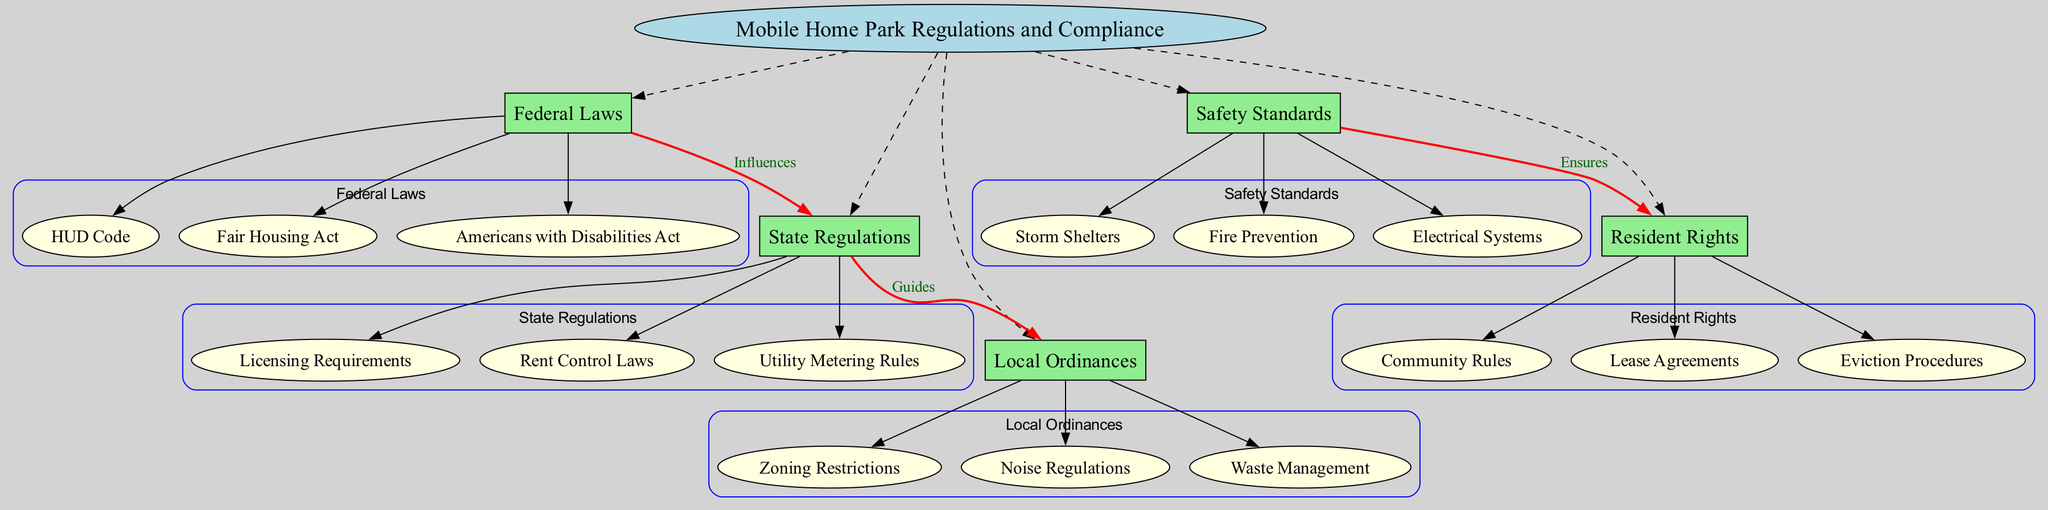What is the central concept of the diagram? The central concept is explicitly stated in the diagram at the center. After reviewing the diagram, it is confirmed to be "Mobile Home Park Regulations and Compliance."
Answer: Mobile Home Park Regulations and Compliance How many main nodes are there? The diagram lists five main nodes connected to the central concept. Counting these nodes yields a total of five.
Answer: 5 Which federal law relates to housing? One of the sub-nodes listed under "Federal Laws" is "Fair Housing Act," which specifically addresses housing issues.
Answer: Fair Housing Act What guides the local ordinances? The edge labeled "Guides" from "State Regulations" to "Local Ordinances" indicates that state regulations influence or guide local ordinances.
Answer: State Regulations What ensures resident rights regarding safety standards? The connection labeled "Ensures" between "Safety Standards" and "Resident Rights" indicates that the safety standards put forth ensure residents' rights are upheld.
Answer: Safety Standards Which local ordinance relates to sound issues? The sub-node "Noise Regulations" under "Local Ordinances" addresses sound issues directly. This can be identified by examining the local ordinances.
Answer: Noise Regulations What is the relationship between federal laws and state regulations? The connection is labeled "Influences," indicating that federal laws affect or influence state regulations, which is visually represented in the diagram.
Answer: Influences How many safety standards are listed? The sub-nodes under "Safety Standards" include three items: "Fire Prevention," "Electrical Systems," and "Storm Shelters." Counting these gives a total of three safety standards.
Answer: 3 What are the eviction procedures considered under? The sub-node "Eviction Procedures" falls under "Resident Rights," thus associating eviction processes with resident rights in the park.
Answer: Resident Rights 